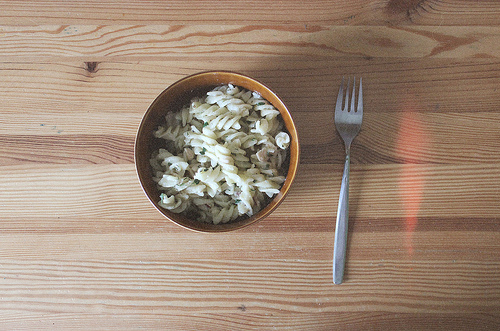<image>
Is there a pasta in front of the bowl? No. The pasta is not in front of the bowl. The spatial positioning shows a different relationship between these objects. 